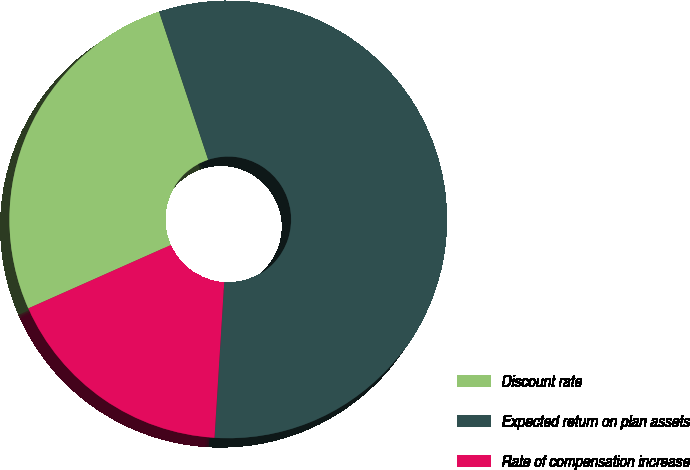Convert chart. <chart><loc_0><loc_0><loc_500><loc_500><pie_chart><fcel>Discount rate<fcel>Expected return on plan assets<fcel>Rate of compensation increase<nl><fcel>26.56%<fcel>56.09%<fcel>17.35%<nl></chart> 